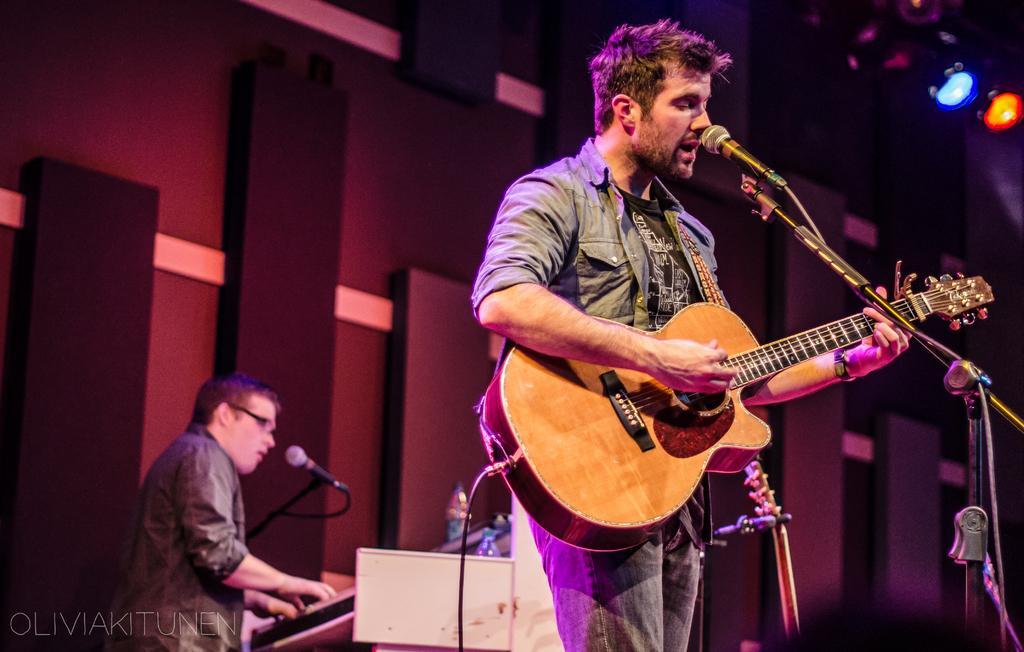Can you describe this image briefly? In the image we can see there is a man who is holding guitar in his hand and at the back there is a person who is playing another musical instrument. 